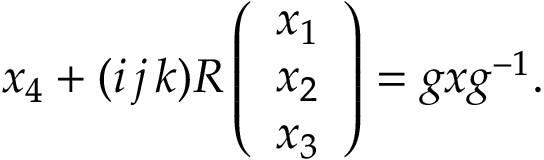<formula> <loc_0><loc_0><loc_500><loc_500>x _ { 4 } + ( i \, j \, k ) R \left ( \begin{array} { c } { { x _ { 1 } } } \\ { { x _ { 2 } } } \\ { { x _ { 3 } } } \end{array} \right ) = g x g ^ { - 1 } .</formula> 